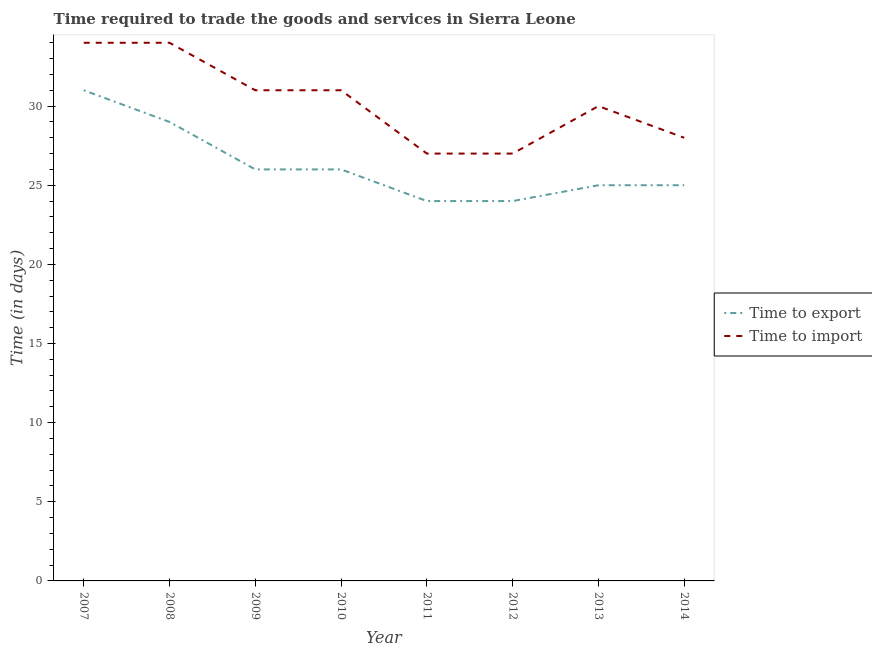How many different coloured lines are there?
Provide a short and direct response. 2. Does the line corresponding to time to export intersect with the line corresponding to time to import?
Your answer should be compact. No. Is the number of lines equal to the number of legend labels?
Offer a very short reply. Yes. What is the time to import in 2010?
Make the answer very short. 31. Across all years, what is the maximum time to import?
Give a very brief answer. 34. Across all years, what is the minimum time to export?
Your response must be concise. 24. In which year was the time to export minimum?
Ensure brevity in your answer.  2011. What is the total time to import in the graph?
Keep it short and to the point. 242. What is the difference between the time to export in 2013 and that in 2014?
Your response must be concise. 0. What is the difference between the time to import in 2008 and the time to export in 2009?
Keep it short and to the point. 8. What is the average time to import per year?
Offer a very short reply. 30.25. In the year 2007, what is the difference between the time to export and time to import?
Offer a terse response. -3. What is the ratio of the time to export in 2007 to that in 2012?
Your response must be concise. 1.29. Is the time to export in 2007 less than that in 2010?
Provide a short and direct response. No. What is the difference between the highest and the second highest time to import?
Your response must be concise. 0. What is the difference between the highest and the lowest time to import?
Offer a terse response. 7. In how many years, is the time to export greater than the average time to export taken over all years?
Your answer should be compact. 2. Is the sum of the time to export in 2010 and 2013 greater than the maximum time to import across all years?
Offer a very short reply. Yes. Is the time to export strictly greater than the time to import over the years?
Ensure brevity in your answer.  No. How many years are there in the graph?
Provide a short and direct response. 8. Are the values on the major ticks of Y-axis written in scientific E-notation?
Your response must be concise. No. What is the title of the graph?
Your answer should be compact. Time required to trade the goods and services in Sierra Leone. Does "Transport services" appear as one of the legend labels in the graph?
Give a very brief answer. No. What is the label or title of the X-axis?
Offer a terse response. Year. What is the label or title of the Y-axis?
Offer a terse response. Time (in days). What is the Time (in days) in Time to import in 2008?
Provide a succinct answer. 34. What is the Time (in days) in Time to export in 2009?
Your response must be concise. 26. What is the Time (in days) in Time to export in 2010?
Offer a very short reply. 26. What is the Time (in days) of Time to import in 2010?
Your response must be concise. 31. What is the Time (in days) of Time to export in 2011?
Offer a terse response. 24. What is the Time (in days) of Time to import in 2014?
Keep it short and to the point. 28. Across all years, what is the maximum Time (in days) of Time to export?
Give a very brief answer. 31. Across all years, what is the maximum Time (in days) in Time to import?
Provide a succinct answer. 34. Across all years, what is the minimum Time (in days) in Time to export?
Give a very brief answer. 24. Across all years, what is the minimum Time (in days) of Time to import?
Provide a succinct answer. 27. What is the total Time (in days) in Time to export in the graph?
Offer a terse response. 210. What is the total Time (in days) of Time to import in the graph?
Offer a terse response. 242. What is the difference between the Time (in days) in Time to import in 2007 and that in 2008?
Provide a succinct answer. 0. What is the difference between the Time (in days) in Time to export in 2007 and that in 2009?
Offer a terse response. 5. What is the difference between the Time (in days) in Time to export in 2007 and that in 2011?
Offer a very short reply. 7. What is the difference between the Time (in days) of Time to import in 2007 and that in 2013?
Your answer should be compact. 4. What is the difference between the Time (in days) in Time to export in 2008 and that in 2009?
Your response must be concise. 3. What is the difference between the Time (in days) of Time to import in 2008 and that in 2010?
Keep it short and to the point. 3. What is the difference between the Time (in days) in Time to export in 2008 and that in 2011?
Make the answer very short. 5. What is the difference between the Time (in days) in Time to import in 2008 and that in 2011?
Ensure brevity in your answer.  7. What is the difference between the Time (in days) in Time to export in 2008 and that in 2012?
Provide a succinct answer. 5. What is the difference between the Time (in days) of Time to export in 2008 and that in 2013?
Offer a terse response. 4. What is the difference between the Time (in days) of Time to export in 2008 and that in 2014?
Offer a very short reply. 4. What is the difference between the Time (in days) in Time to import in 2008 and that in 2014?
Your answer should be compact. 6. What is the difference between the Time (in days) of Time to export in 2009 and that in 2011?
Offer a very short reply. 2. What is the difference between the Time (in days) in Time to export in 2009 and that in 2012?
Keep it short and to the point. 2. What is the difference between the Time (in days) of Time to import in 2009 and that in 2012?
Keep it short and to the point. 4. What is the difference between the Time (in days) of Time to export in 2009 and that in 2013?
Provide a short and direct response. 1. What is the difference between the Time (in days) in Time to export in 2009 and that in 2014?
Your response must be concise. 1. What is the difference between the Time (in days) in Time to export in 2010 and that in 2011?
Your answer should be very brief. 2. What is the difference between the Time (in days) in Time to export in 2011 and that in 2012?
Provide a succinct answer. 0. What is the difference between the Time (in days) in Time to import in 2011 and that in 2013?
Offer a very short reply. -3. What is the difference between the Time (in days) of Time to import in 2011 and that in 2014?
Keep it short and to the point. -1. What is the difference between the Time (in days) in Time to import in 2012 and that in 2013?
Offer a very short reply. -3. What is the difference between the Time (in days) in Time to export in 2012 and that in 2014?
Offer a terse response. -1. What is the difference between the Time (in days) in Time to import in 2012 and that in 2014?
Provide a short and direct response. -1. What is the difference between the Time (in days) in Time to export in 2013 and that in 2014?
Offer a very short reply. 0. What is the difference between the Time (in days) of Time to import in 2013 and that in 2014?
Provide a succinct answer. 2. What is the difference between the Time (in days) in Time to export in 2007 and the Time (in days) in Time to import in 2011?
Make the answer very short. 4. What is the difference between the Time (in days) in Time to export in 2007 and the Time (in days) in Time to import in 2012?
Your answer should be very brief. 4. What is the difference between the Time (in days) in Time to export in 2007 and the Time (in days) in Time to import in 2014?
Your answer should be compact. 3. What is the difference between the Time (in days) of Time to export in 2008 and the Time (in days) of Time to import in 2011?
Offer a very short reply. 2. What is the difference between the Time (in days) of Time to export in 2008 and the Time (in days) of Time to import in 2013?
Ensure brevity in your answer.  -1. What is the difference between the Time (in days) in Time to export in 2009 and the Time (in days) in Time to import in 2011?
Keep it short and to the point. -1. What is the difference between the Time (in days) in Time to export in 2009 and the Time (in days) in Time to import in 2012?
Provide a succinct answer. -1. What is the difference between the Time (in days) in Time to export in 2010 and the Time (in days) in Time to import in 2012?
Offer a terse response. -1. What is the difference between the Time (in days) in Time to export in 2012 and the Time (in days) in Time to import in 2013?
Make the answer very short. -6. What is the difference between the Time (in days) of Time to export in 2013 and the Time (in days) of Time to import in 2014?
Give a very brief answer. -3. What is the average Time (in days) of Time to export per year?
Your response must be concise. 26.25. What is the average Time (in days) of Time to import per year?
Offer a very short reply. 30.25. In the year 2008, what is the difference between the Time (in days) of Time to export and Time (in days) of Time to import?
Give a very brief answer. -5. In the year 2011, what is the difference between the Time (in days) in Time to export and Time (in days) in Time to import?
Ensure brevity in your answer.  -3. In the year 2013, what is the difference between the Time (in days) of Time to export and Time (in days) of Time to import?
Offer a terse response. -5. What is the ratio of the Time (in days) of Time to export in 2007 to that in 2008?
Provide a short and direct response. 1.07. What is the ratio of the Time (in days) of Time to import in 2007 to that in 2008?
Ensure brevity in your answer.  1. What is the ratio of the Time (in days) in Time to export in 2007 to that in 2009?
Keep it short and to the point. 1.19. What is the ratio of the Time (in days) in Time to import in 2007 to that in 2009?
Your answer should be compact. 1.1. What is the ratio of the Time (in days) in Time to export in 2007 to that in 2010?
Keep it short and to the point. 1.19. What is the ratio of the Time (in days) of Time to import in 2007 to that in 2010?
Your answer should be very brief. 1.1. What is the ratio of the Time (in days) of Time to export in 2007 to that in 2011?
Provide a succinct answer. 1.29. What is the ratio of the Time (in days) of Time to import in 2007 to that in 2011?
Your response must be concise. 1.26. What is the ratio of the Time (in days) of Time to export in 2007 to that in 2012?
Offer a terse response. 1.29. What is the ratio of the Time (in days) in Time to import in 2007 to that in 2012?
Your answer should be compact. 1.26. What is the ratio of the Time (in days) in Time to export in 2007 to that in 2013?
Give a very brief answer. 1.24. What is the ratio of the Time (in days) of Time to import in 2007 to that in 2013?
Your answer should be very brief. 1.13. What is the ratio of the Time (in days) in Time to export in 2007 to that in 2014?
Give a very brief answer. 1.24. What is the ratio of the Time (in days) of Time to import in 2007 to that in 2014?
Ensure brevity in your answer.  1.21. What is the ratio of the Time (in days) of Time to export in 2008 to that in 2009?
Your answer should be very brief. 1.12. What is the ratio of the Time (in days) in Time to import in 2008 to that in 2009?
Offer a terse response. 1.1. What is the ratio of the Time (in days) in Time to export in 2008 to that in 2010?
Your answer should be compact. 1.12. What is the ratio of the Time (in days) of Time to import in 2008 to that in 2010?
Ensure brevity in your answer.  1.1. What is the ratio of the Time (in days) in Time to export in 2008 to that in 2011?
Offer a very short reply. 1.21. What is the ratio of the Time (in days) in Time to import in 2008 to that in 2011?
Your answer should be very brief. 1.26. What is the ratio of the Time (in days) in Time to export in 2008 to that in 2012?
Keep it short and to the point. 1.21. What is the ratio of the Time (in days) in Time to import in 2008 to that in 2012?
Give a very brief answer. 1.26. What is the ratio of the Time (in days) in Time to export in 2008 to that in 2013?
Offer a very short reply. 1.16. What is the ratio of the Time (in days) of Time to import in 2008 to that in 2013?
Offer a very short reply. 1.13. What is the ratio of the Time (in days) in Time to export in 2008 to that in 2014?
Provide a short and direct response. 1.16. What is the ratio of the Time (in days) of Time to import in 2008 to that in 2014?
Ensure brevity in your answer.  1.21. What is the ratio of the Time (in days) in Time to export in 2009 to that in 2010?
Keep it short and to the point. 1. What is the ratio of the Time (in days) in Time to import in 2009 to that in 2010?
Provide a succinct answer. 1. What is the ratio of the Time (in days) in Time to export in 2009 to that in 2011?
Keep it short and to the point. 1.08. What is the ratio of the Time (in days) in Time to import in 2009 to that in 2011?
Keep it short and to the point. 1.15. What is the ratio of the Time (in days) in Time to import in 2009 to that in 2012?
Ensure brevity in your answer.  1.15. What is the ratio of the Time (in days) in Time to import in 2009 to that in 2013?
Your answer should be very brief. 1.03. What is the ratio of the Time (in days) in Time to import in 2009 to that in 2014?
Make the answer very short. 1.11. What is the ratio of the Time (in days) of Time to export in 2010 to that in 2011?
Give a very brief answer. 1.08. What is the ratio of the Time (in days) of Time to import in 2010 to that in 2011?
Provide a succinct answer. 1.15. What is the ratio of the Time (in days) of Time to export in 2010 to that in 2012?
Your answer should be very brief. 1.08. What is the ratio of the Time (in days) in Time to import in 2010 to that in 2012?
Provide a short and direct response. 1.15. What is the ratio of the Time (in days) of Time to export in 2010 to that in 2013?
Provide a succinct answer. 1.04. What is the ratio of the Time (in days) in Time to import in 2010 to that in 2013?
Your answer should be compact. 1.03. What is the ratio of the Time (in days) in Time to export in 2010 to that in 2014?
Your response must be concise. 1.04. What is the ratio of the Time (in days) of Time to import in 2010 to that in 2014?
Offer a very short reply. 1.11. What is the ratio of the Time (in days) of Time to export in 2011 to that in 2013?
Make the answer very short. 0.96. What is the ratio of the Time (in days) of Time to import in 2011 to that in 2013?
Your answer should be compact. 0.9. What is the ratio of the Time (in days) of Time to import in 2011 to that in 2014?
Your answer should be compact. 0.96. What is the ratio of the Time (in days) in Time to export in 2012 to that in 2013?
Offer a very short reply. 0.96. What is the ratio of the Time (in days) in Time to import in 2012 to that in 2013?
Your answer should be compact. 0.9. What is the ratio of the Time (in days) in Time to export in 2012 to that in 2014?
Offer a terse response. 0.96. What is the ratio of the Time (in days) in Time to export in 2013 to that in 2014?
Make the answer very short. 1. What is the ratio of the Time (in days) in Time to import in 2013 to that in 2014?
Make the answer very short. 1.07. What is the difference between the highest and the second highest Time (in days) of Time to export?
Keep it short and to the point. 2. What is the difference between the highest and the lowest Time (in days) of Time to export?
Provide a short and direct response. 7. What is the difference between the highest and the lowest Time (in days) of Time to import?
Your answer should be compact. 7. 